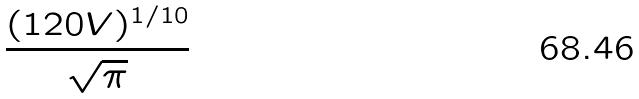<formula> <loc_0><loc_0><loc_500><loc_500>\frac { ( 1 2 0 V ) ^ { 1 / 1 0 } } { \sqrt { \pi } }</formula> 